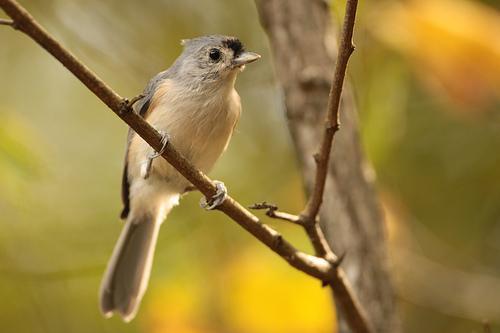How many birds are pictured?
Give a very brief answer. 1. How many birds are there?
Give a very brief answer. 1. How many legs does the bird have?
Give a very brief answer. 2. 